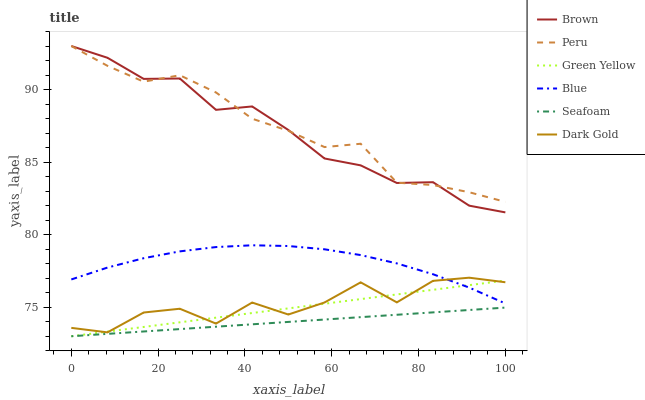Does Seafoam have the minimum area under the curve?
Answer yes or no. Yes. Does Peru have the maximum area under the curve?
Answer yes or no. Yes. Does Brown have the minimum area under the curve?
Answer yes or no. No. Does Brown have the maximum area under the curve?
Answer yes or no. No. Is Green Yellow the smoothest?
Answer yes or no. Yes. Is Dark Gold the roughest?
Answer yes or no. Yes. Is Brown the smoothest?
Answer yes or no. No. Is Brown the roughest?
Answer yes or no. No. Does Brown have the lowest value?
Answer yes or no. No. Does Peru have the highest value?
Answer yes or no. Yes. Does Dark Gold have the highest value?
Answer yes or no. No. Is Blue less than Brown?
Answer yes or no. Yes. Is Peru greater than Blue?
Answer yes or no. Yes. Does Dark Gold intersect Green Yellow?
Answer yes or no. Yes. Is Dark Gold less than Green Yellow?
Answer yes or no. No. Is Dark Gold greater than Green Yellow?
Answer yes or no. No. Does Blue intersect Brown?
Answer yes or no. No. 